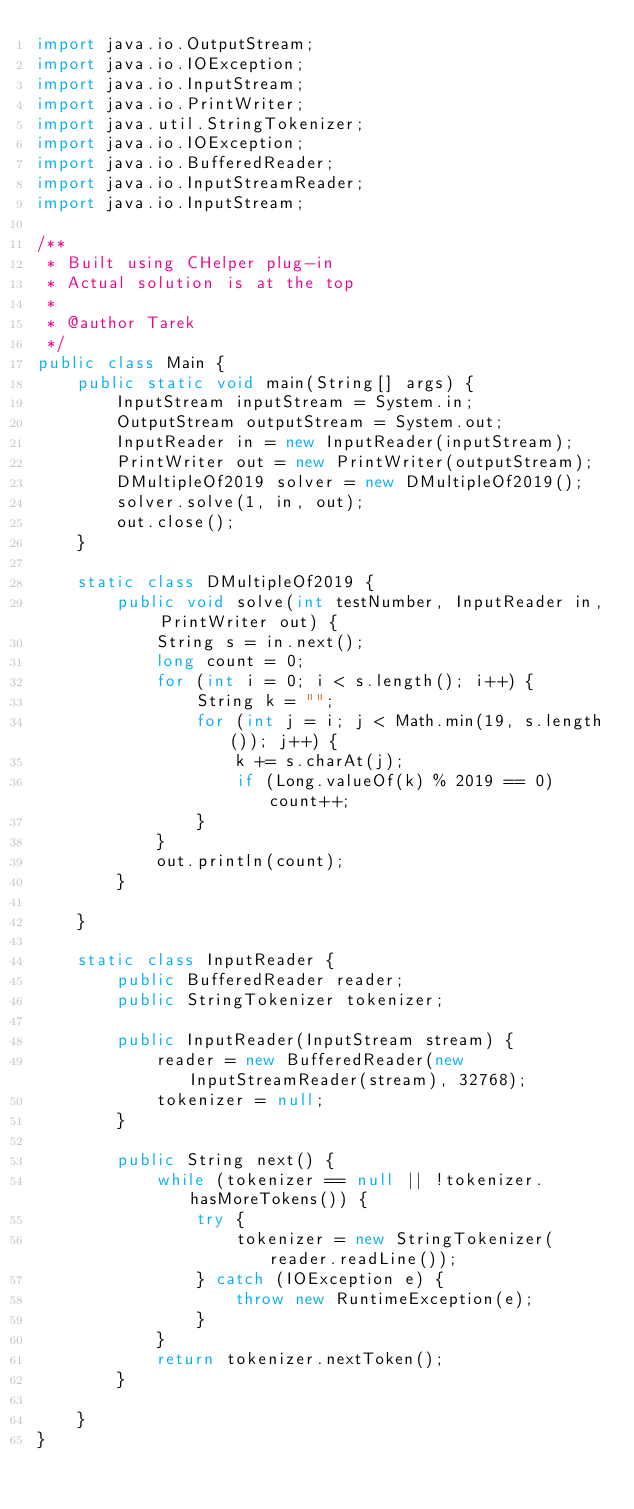Convert code to text. <code><loc_0><loc_0><loc_500><loc_500><_Java_>import java.io.OutputStream;
import java.io.IOException;
import java.io.InputStream;
import java.io.PrintWriter;
import java.util.StringTokenizer;
import java.io.IOException;
import java.io.BufferedReader;
import java.io.InputStreamReader;
import java.io.InputStream;

/**
 * Built using CHelper plug-in
 * Actual solution is at the top
 *
 * @author Tarek
 */
public class Main {
    public static void main(String[] args) {
        InputStream inputStream = System.in;
        OutputStream outputStream = System.out;
        InputReader in = new InputReader(inputStream);
        PrintWriter out = new PrintWriter(outputStream);
        DMultipleOf2019 solver = new DMultipleOf2019();
        solver.solve(1, in, out);
        out.close();
    }

    static class DMultipleOf2019 {
        public void solve(int testNumber, InputReader in, PrintWriter out) {
            String s = in.next();
            long count = 0;
            for (int i = 0; i < s.length(); i++) {
                String k = "";
                for (int j = i; j < Math.min(19, s.length()); j++) {
                    k += s.charAt(j);
                    if (Long.valueOf(k) % 2019 == 0) count++;
                }
            }
            out.println(count);
        }

    }

    static class InputReader {
        public BufferedReader reader;
        public StringTokenizer tokenizer;

        public InputReader(InputStream stream) {
            reader = new BufferedReader(new InputStreamReader(stream), 32768);
            tokenizer = null;
        }

        public String next() {
            while (tokenizer == null || !tokenizer.hasMoreTokens()) {
                try {
                    tokenizer = new StringTokenizer(reader.readLine());
                } catch (IOException e) {
                    throw new RuntimeException(e);
                }
            }
            return tokenizer.nextToken();
        }

    }
}

</code> 